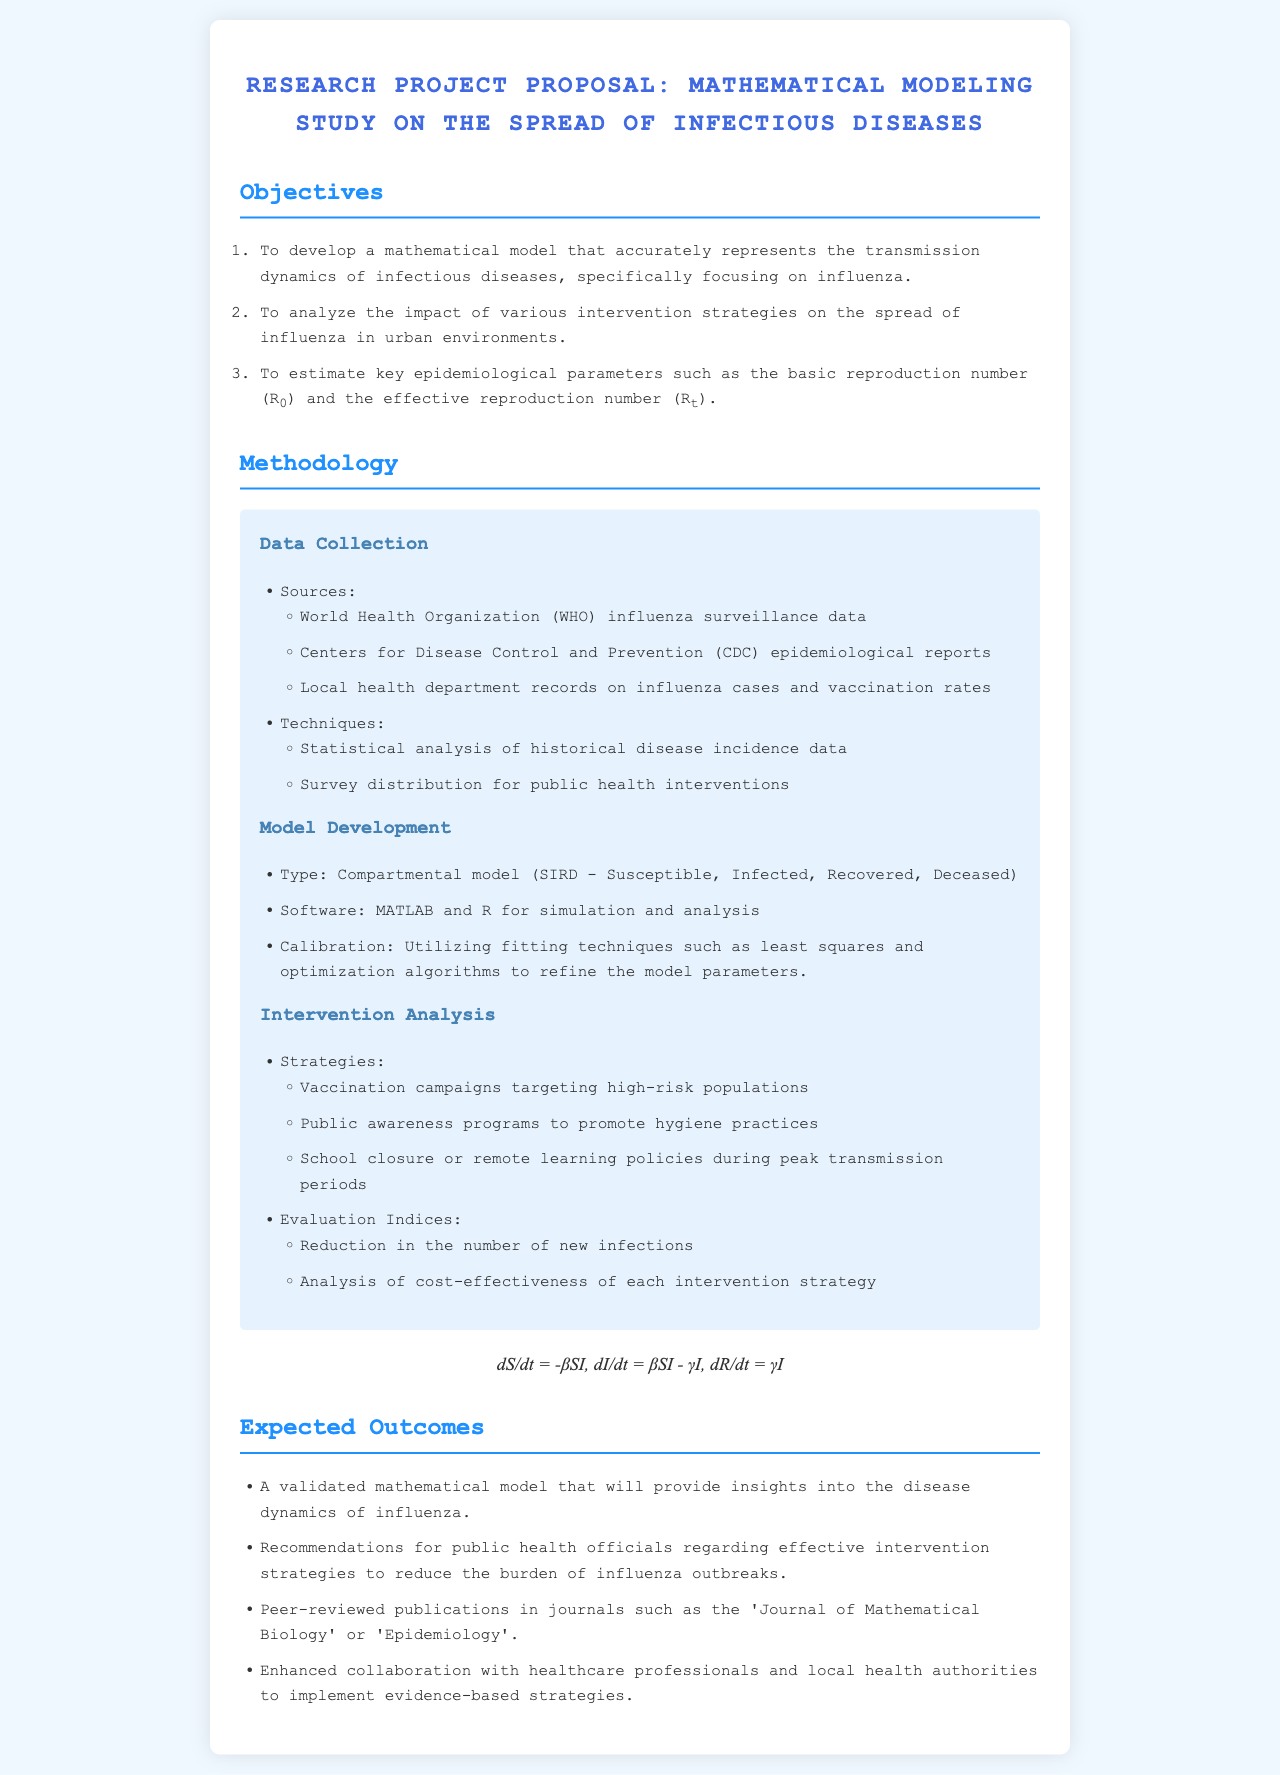What is the focus of the mathematical modeling study? The study focuses on the transmission dynamics of infectious diseases, specifically influenza.
Answer: Influenza Who are the primary data sources for this research? The primary data sources include the World Health Organization, Centers for Disease Control and Prevention, and local health department records.
Answer: WHO, CDC, local health departments What type of model is being developed? The type of model being developed is a compartmental model known as SIRD.
Answer: SIRD What software will be used for simulation and analysis? The software used for simulation and analysis will be MATLAB and R.
Answer: MATLAB and R What is one of the expected outcomes of the study? One expected outcome is a validated mathematical model providing insights into disease dynamics.
Answer: Validated mathematical model Which journal is mentioned for potential peer-reviewed publications? 'Journal of Mathematical Biology' is mentioned as a potential publication venue.
Answer: Journal of Mathematical Biology What intervention strategy is aimed at high-risk populations? The intervention strategy aimed at high-risk populations is vaccination campaigns.
Answer: Vaccination campaigns What is the mathematical formula presented in the document? The formula presented is the system of equations for the disease dynamics.
Answer: dS/dt = -βSI, dI/dt = βSI - γI, dR/dt = γI 